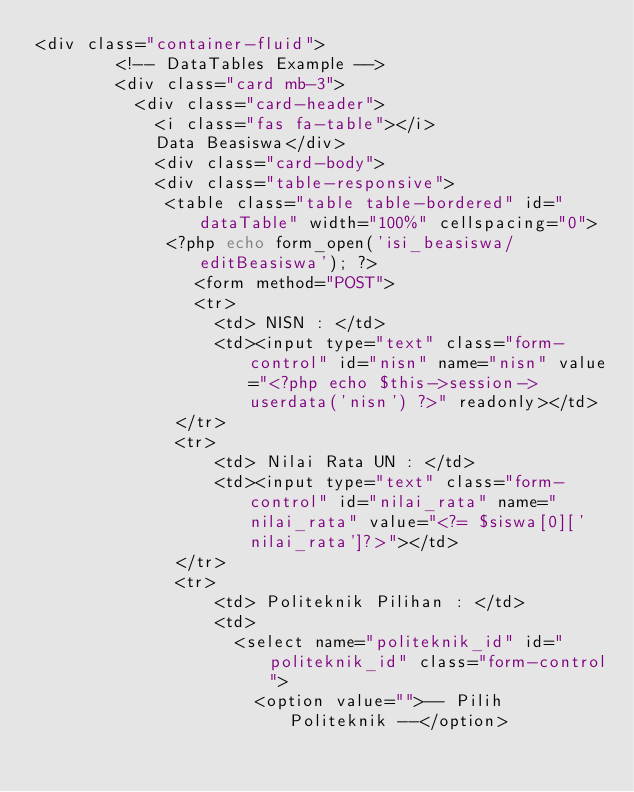Convert code to text. <code><loc_0><loc_0><loc_500><loc_500><_PHP_><div class="container-fluid">
        <!-- DataTables Example -->
        <div class="card mb-3">
          <div class="card-header">
            <i class="fas fa-table"></i>
            Data Beasiswa</div>
            <div class="card-body">
            <div class="table-responsive">
             <table class="table table-bordered" id="dataTable" width="100%" cellspacing="0">
             <?php echo form_open('isi_beasiswa/editBeasiswa'); ?>
                <form method="POST">
                <tr>
                  <td> NISN : </td>
                  <td><input type="text" class="form-control" id="nisn" name="nisn" value="<?php echo $this->session->userdata('nisn') ?>" readonly></td>
              </tr>
              <tr>
                  <td> Nilai Rata UN : </td>
                  <td><input type="text" class="form-control" id="nilai_rata" name="nilai_rata" value="<?= $siswa[0]['nilai_rata']?>"></td>
              </tr>
              <tr>
                  <td> Politeknik Pilihan : </td>
                  <td> 
                    <select name="politeknik_id" id="politeknik_id" class="form-control">
                      <option value="">-- Pilih Politeknik --</option></code> 